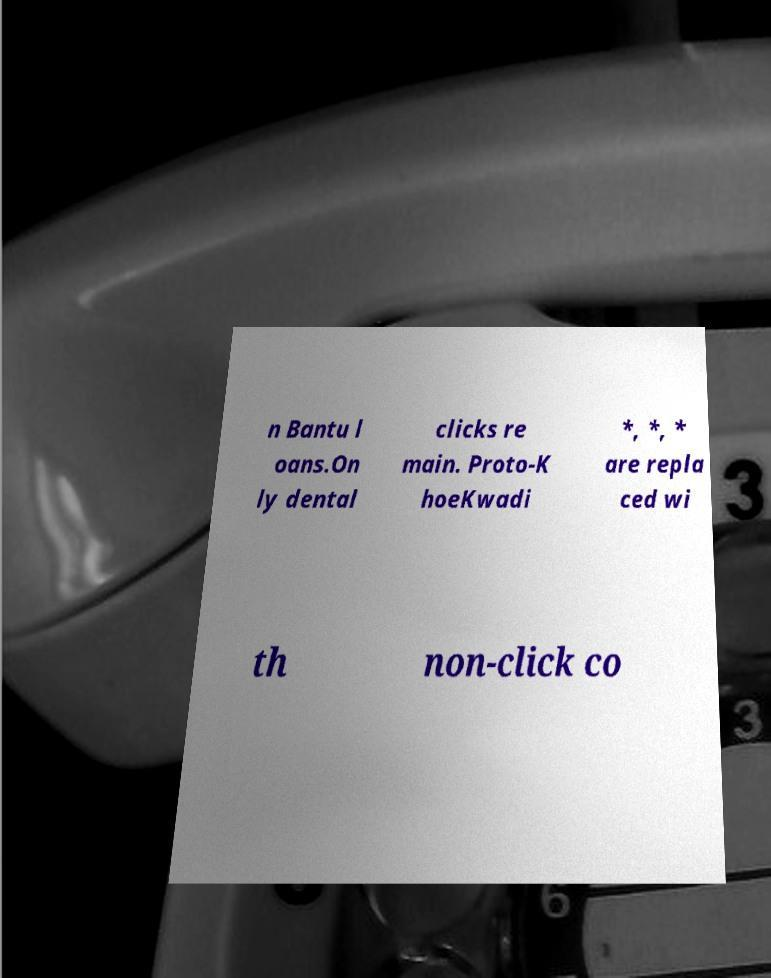There's text embedded in this image that I need extracted. Can you transcribe it verbatim? n Bantu l oans.On ly dental clicks re main. Proto-K hoeKwadi *, *, * are repla ced wi th non-click co 